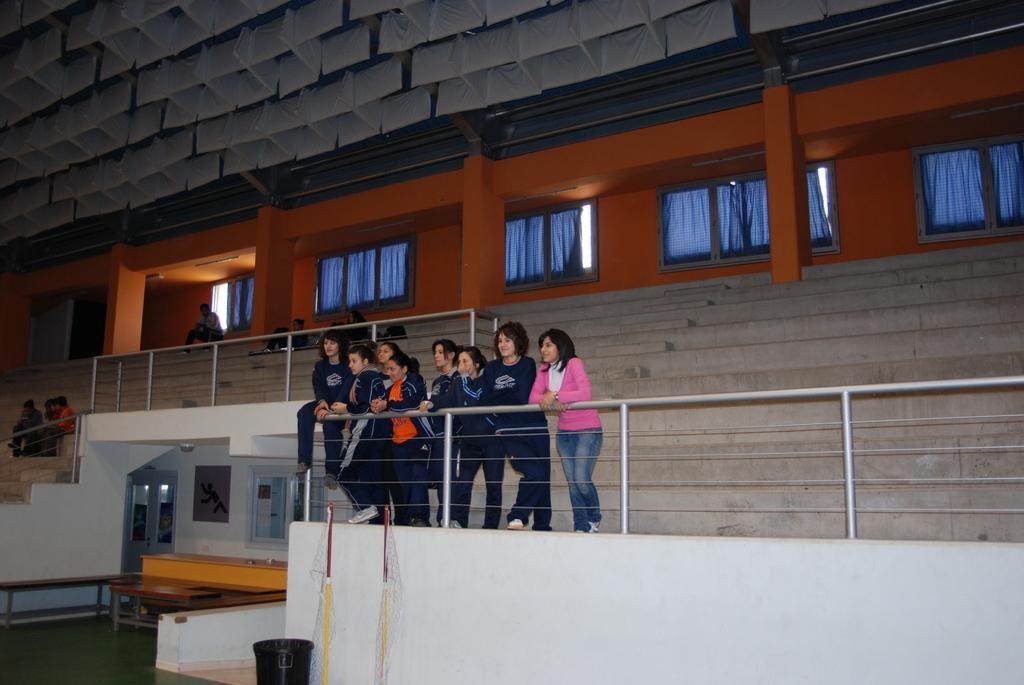Please provide a concise description of this image. In the center of the image we can see many persons standing at the stairs. On the left side of the image we can see persons sitting on the stairs. In the background we can see pillars, stairs, windows and curtains. At the bottom of the image we can see door, bench and table. 